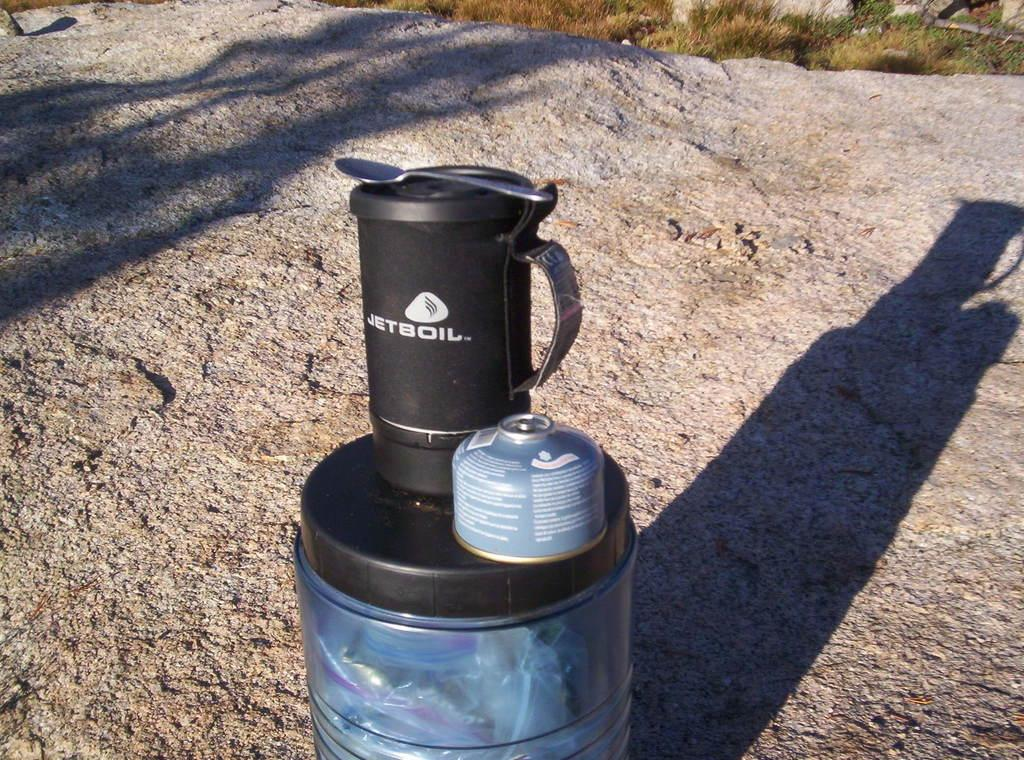<image>
Provide a brief description of the given image. A Jetboil water bottle rests on a rock outside. 